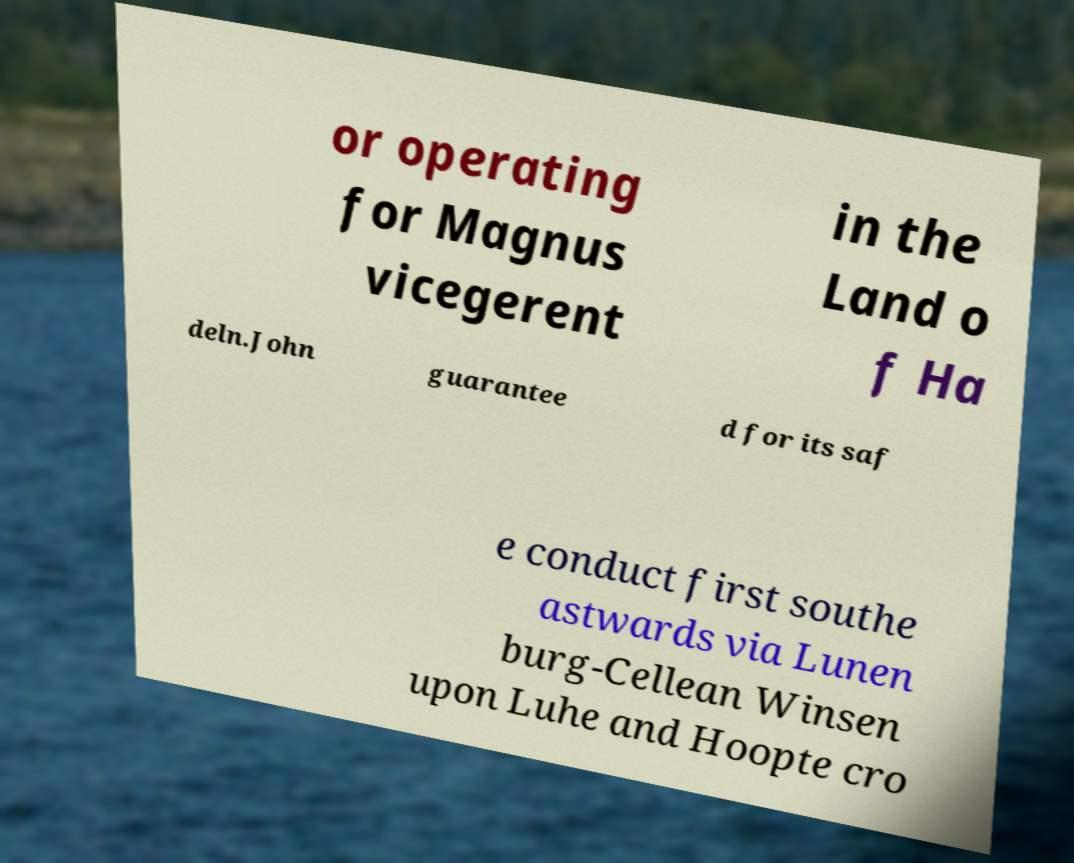Can you read and provide the text displayed in the image?This photo seems to have some interesting text. Can you extract and type it out for me? or operating for Magnus vicegerent in the Land o f Ha deln.John guarantee d for its saf e conduct first southe astwards via Lunen burg-Cellean Winsen upon Luhe and Hoopte cro 